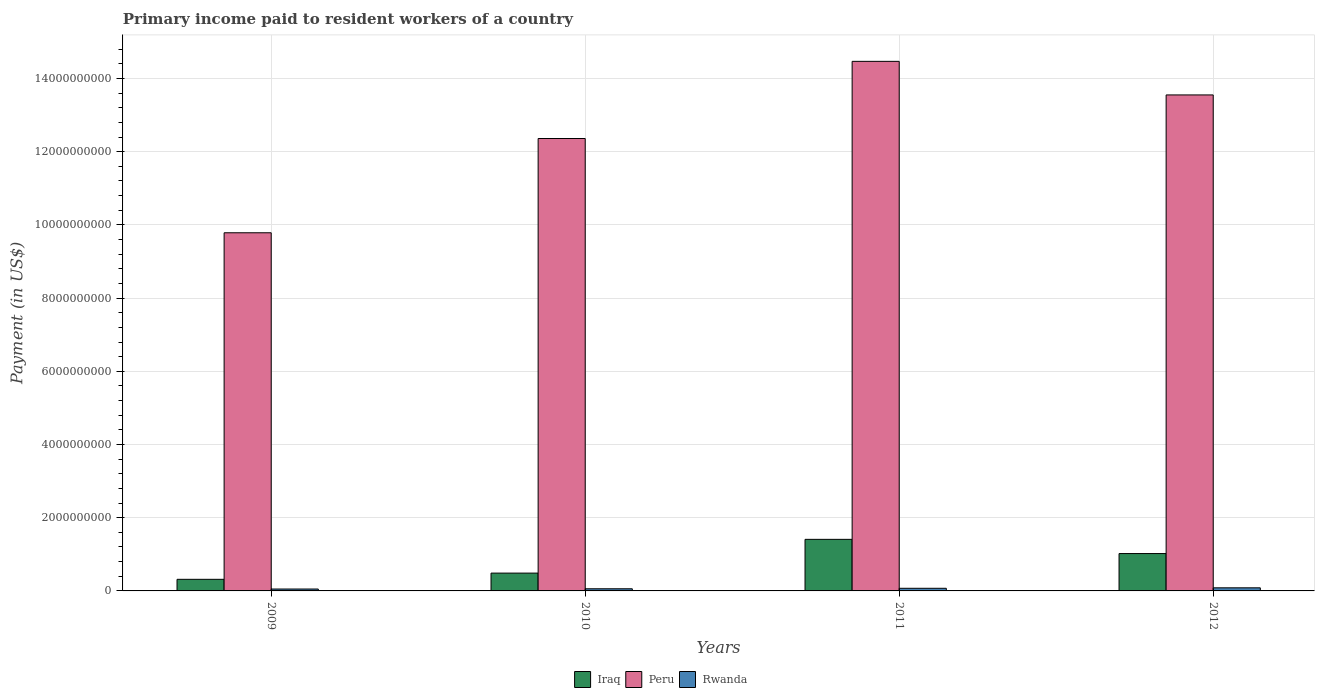How many groups of bars are there?
Offer a very short reply. 4. Are the number of bars per tick equal to the number of legend labels?
Your response must be concise. Yes. Are the number of bars on each tick of the X-axis equal?
Your answer should be very brief. Yes. How many bars are there on the 3rd tick from the left?
Provide a short and direct response. 3. What is the label of the 3rd group of bars from the left?
Your response must be concise. 2011. In how many cases, is the number of bars for a given year not equal to the number of legend labels?
Provide a succinct answer. 0. What is the amount paid to workers in Peru in 2010?
Make the answer very short. 1.24e+1. Across all years, what is the maximum amount paid to workers in Peru?
Ensure brevity in your answer.  1.45e+1. Across all years, what is the minimum amount paid to workers in Peru?
Give a very brief answer. 9.79e+09. In which year was the amount paid to workers in Rwanda maximum?
Your answer should be compact. 2012. In which year was the amount paid to workers in Peru minimum?
Your answer should be very brief. 2009. What is the total amount paid to workers in Iraq in the graph?
Provide a succinct answer. 3.23e+09. What is the difference between the amount paid to workers in Peru in 2009 and that in 2010?
Your response must be concise. -2.58e+09. What is the difference between the amount paid to workers in Iraq in 2011 and the amount paid to workers in Rwanda in 2012?
Your answer should be compact. 1.32e+09. What is the average amount paid to workers in Iraq per year?
Your response must be concise. 8.08e+08. In the year 2012, what is the difference between the amount paid to workers in Peru and amount paid to workers in Iraq?
Offer a terse response. 1.25e+1. In how many years, is the amount paid to workers in Rwanda greater than 9200000000 US$?
Your answer should be compact. 0. What is the ratio of the amount paid to workers in Peru in 2009 to that in 2012?
Provide a succinct answer. 0.72. What is the difference between the highest and the second highest amount paid to workers in Iraq?
Keep it short and to the point. 3.88e+08. What is the difference between the highest and the lowest amount paid to workers in Rwanda?
Your answer should be compact. 3.28e+07. What does the 3rd bar from the left in 2012 represents?
Your response must be concise. Rwanda. What does the 2nd bar from the right in 2010 represents?
Your answer should be compact. Peru. Is it the case that in every year, the sum of the amount paid to workers in Rwanda and amount paid to workers in Peru is greater than the amount paid to workers in Iraq?
Make the answer very short. Yes. How many bars are there?
Your answer should be compact. 12. Does the graph contain any zero values?
Your answer should be compact. No. Does the graph contain grids?
Your answer should be very brief. Yes. How many legend labels are there?
Offer a terse response. 3. How are the legend labels stacked?
Keep it short and to the point. Horizontal. What is the title of the graph?
Give a very brief answer. Primary income paid to resident workers of a country. Does "India" appear as one of the legend labels in the graph?
Your answer should be compact. No. What is the label or title of the X-axis?
Make the answer very short. Years. What is the label or title of the Y-axis?
Offer a terse response. Payment (in US$). What is the Payment (in US$) of Iraq in 2009?
Your answer should be compact. 3.17e+08. What is the Payment (in US$) of Peru in 2009?
Offer a very short reply. 9.79e+09. What is the Payment (in US$) in Rwanda in 2009?
Give a very brief answer. 5.17e+07. What is the Payment (in US$) of Iraq in 2010?
Your answer should be very brief. 4.87e+08. What is the Payment (in US$) of Peru in 2010?
Provide a short and direct response. 1.24e+1. What is the Payment (in US$) of Rwanda in 2010?
Offer a very short reply. 5.86e+07. What is the Payment (in US$) in Iraq in 2011?
Keep it short and to the point. 1.41e+09. What is the Payment (in US$) of Peru in 2011?
Your response must be concise. 1.45e+1. What is the Payment (in US$) of Rwanda in 2011?
Keep it short and to the point. 7.19e+07. What is the Payment (in US$) in Iraq in 2012?
Provide a succinct answer. 1.02e+09. What is the Payment (in US$) of Peru in 2012?
Keep it short and to the point. 1.36e+1. What is the Payment (in US$) of Rwanda in 2012?
Make the answer very short. 8.45e+07. Across all years, what is the maximum Payment (in US$) of Iraq?
Offer a very short reply. 1.41e+09. Across all years, what is the maximum Payment (in US$) of Peru?
Provide a short and direct response. 1.45e+1. Across all years, what is the maximum Payment (in US$) in Rwanda?
Give a very brief answer. 8.45e+07. Across all years, what is the minimum Payment (in US$) of Iraq?
Your response must be concise. 3.17e+08. Across all years, what is the minimum Payment (in US$) of Peru?
Offer a very short reply. 9.79e+09. Across all years, what is the minimum Payment (in US$) of Rwanda?
Keep it short and to the point. 5.17e+07. What is the total Payment (in US$) of Iraq in the graph?
Your response must be concise. 3.23e+09. What is the total Payment (in US$) in Peru in the graph?
Keep it short and to the point. 5.02e+1. What is the total Payment (in US$) of Rwanda in the graph?
Your answer should be very brief. 2.67e+08. What is the difference between the Payment (in US$) in Iraq in 2009 and that in 2010?
Give a very brief answer. -1.70e+08. What is the difference between the Payment (in US$) of Peru in 2009 and that in 2010?
Give a very brief answer. -2.58e+09. What is the difference between the Payment (in US$) in Rwanda in 2009 and that in 2010?
Offer a terse response. -6.93e+06. What is the difference between the Payment (in US$) in Iraq in 2009 and that in 2011?
Your answer should be compact. -1.09e+09. What is the difference between the Payment (in US$) of Peru in 2009 and that in 2011?
Provide a succinct answer. -4.68e+09. What is the difference between the Payment (in US$) in Rwanda in 2009 and that in 2011?
Give a very brief answer. -2.02e+07. What is the difference between the Payment (in US$) in Iraq in 2009 and that in 2012?
Your answer should be compact. -7.04e+08. What is the difference between the Payment (in US$) of Peru in 2009 and that in 2012?
Provide a succinct answer. -3.77e+09. What is the difference between the Payment (in US$) in Rwanda in 2009 and that in 2012?
Provide a short and direct response. -3.28e+07. What is the difference between the Payment (in US$) of Iraq in 2010 and that in 2011?
Your answer should be very brief. -9.22e+08. What is the difference between the Payment (in US$) of Peru in 2010 and that in 2011?
Your answer should be compact. -2.11e+09. What is the difference between the Payment (in US$) of Rwanda in 2010 and that in 2011?
Give a very brief answer. -1.32e+07. What is the difference between the Payment (in US$) of Iraq in 2010 and that in 2012?
Your answer should be compact. -5.34e+08. What is the difference between the Payment (in US$) of Peru in 2010 and that in 2012?
Keep it short and to the point. -1.19e+09. What is the difference between the Payment (in US$) of Rwanda in 2010 and that in 2012?
Your response must be concise. -2.59e+07. What is the difference between the Payment (in US$) in Iraq in 2011 and that in 2012?
Your answer should be very brief. 3.88e+08. What is the difference between the Payment (in US$) in Peru in 2011 and that in 2012?
Your answer should be compact. 9.17e+08. What is the difference between the Payment (in US$) of Rwanda in 2011 and that in 2012?
Your response must be concise. -1.27e+07. What is the difference between the Payment (in US$) in Iraq in 2009 and the Payment (in US$) in Peru in 2010?
Give a very brief answer. -1.20e+1. What is the difference between the Payment (in US$) of Iraq in 2009 and the Payment (in US$) of Rwanda in 2010?
Your answer should be compact. 2.58e+08. What is the difference between the Payment (in US$) in Peru in 2009 and the Payment (in US$) in Rwanda in 2010?
Your response must be concise. 9.73e+09. What is the difference between the Payment (in US$) in Iraq in 2009 and the Payment (in US$) in Peru in 2011?
Your answer should be compact. -1.42e+1. What is the difference between the Payment (in US$) in Iraq in 2009 and the Payment (in US$) in Rwanda in 2011?
Keep it short and to the point. 2.45e+08. What is the difference between the Payment (in US$) in Peru in 2009 and the Payment (in US$) in Rwanda in 2011?
Keep it short and to the point. 9.71e+09. What is the difference between the Payment (in US$) in Iraq in 2009 and the Payment (in US$) in Peru in 2012?
Provide a short and direct response. -1.32e+1. What is the difference between the Payment (in US$) in Iraq in 2009 and the Payment (in US$) in Rwanda in 2012?
Your answer should be very brief. 2.33e+08. What is the difference between the Payment (in US$) in Peru in 2009 and the Payment (in US$) in Rwanda in 2012?
Provide a succinct answer. 9.70e+09. What is the difference between the Payment (in US$) in Iraq in 2010 and the Payment (in US$) in Peru in 2011?
Ensure brevity in your answer.  -1.40e+1. What is the difference between the Payment (in US$) in Iraq in 2010 and the Payment (in US$) in Rwanda in 2011?
Offer a very short reply. 4.15e+08. What is the difference between the Payment (in US$) in Peru in 2010 and the Payment (in US$) in Rwanda in 2011?
Provide a succinct answer. 1.23e+1. What is the difference between the Payment (in US$) of Iraq in 2010 and the Payment (in US$) of Peru in 2012?
Provide a short and direct response. -1.31e+1. What is the difference between the Payment (in US$) of Iraq in 2010 and the Payment (in US$) of Rwanda in 2012?
Provide a succinct answer. 4.02e+08. What is the difference between the Payment (in US$) of Peru in 2010 and the Payment (in US$) of Rwanda in 2012?
Your response must be concise. 1.23e+1. What is the difference between the Payment (in US$) in Iraq in 2011 and the Payment (in US$) in Peru in 2012?
Provide a short and direct response. -1.21e+1. What is the difference between the Payment (in US$) of Iraq in 2011 and the Payment (in US$) of Rwanda in 2012?
Provide a succinct answer. 1.32e+09. What is the difference between the Payment (in US$) of Peru in 2011 and the Payment (in US$) of Rwanda in 2012?
Your answer should be very brief. 1.44e+1. What is the average Payment (in US$) of Iraq per year?
Provide a short and direct response. 8.08e+08. What is the average Payment (in US$) of Peru per year?
Offer a very short reply. 1.25e+1. What is the average Payment (in US$) in Rwanda per year?
Give a very brief answer. 6.67e+07. In the year 2009, what is the difference between the Payment (in US$) in Iraq and Payment (in US$) in Peru?
Ensure brevity in your answer.  -9.47e+09. In the year 2009, what is the difference between the Payment (in US$) of Iraq and Payment (in US$) of Rwanda?
Your answer should be very brief. 2.65e+08. In the year 2009, what is the difference between the Payment (in US$) in Peru and Payment (in US$) in Rwanda?
Keep it short and to the point. 9.73e+09. In the year 2010, what is the difference between the Payment (in US$) of Iraq and Payment (in US$) of Peru?
Give a very brief answer. -1.19e+1. In the year 2010, what is the difference between the Payment (in US$) of Iraq and Payment (in US$) of Rwanda?
Your answer should be very brief. 4.28e+08. In the year 2010, what is the difference between the Payment (in US$) in Peru and Payment (in US$) in Rwanda?
Provide a succinct answer. 1.23e+1. In the year 2011, what is the difference between the Payment (in US$) of Iraq and Payment (in US$) of Peru?
Your answer should be compact. -1.31e+1. In the year 2011, what is the difference between the Payment (in US$) in Iraq and Payment (in US$) in Rwanda?
Keep it short and to the point. 1.34e+09. In the year 2011, what is the difference between the Payment (in US$) in Peru and Payment (in US$) in Rwanda?
Keep it short and to the point. 1.44e+1. In the year 2012, what is the difference between the Payment (in US$) in Iraq and Payment (in US$) in Peru?
Offer a very short reply. -1.25e+1. In the year 2012, what is the difference between the Payment (in US$) of Iraq and Payment (in US$) of Rwanda?
Offer a very short reply. 9.36e+08. In the year 2012, what is the difference between the Payment (in US$) of Peru and Payment (in US$) of Rwanda?
Provide a succinct answer. 1.35e+1. What is the ratio of the Payment (in US$) of Iraq in 2009 to that in 2010?
Provide a succinct answer. 0.65. What is the ratio of the Payment (in US$) of Peru in 2009 to that in 2010?
Make the answer very short. 0.79. What is the ratio of the Payment (in US$) in Rwanda in 2009 to that in 2010?
Provide a succinct answer. 0.88. What is the ratio of the Payment (in US$) of Iraq in 2009 to that in 2011?
Provide a short and direct response. 0.23. What is the ratio of the Payment (in US$) of Peru in 2009 to that in 2011?
Make the answer very short. 0.68. What is the ratio of the Payment (in US$) of Rwanda in 2009 to that in 2011?
Provide a succinct answer. 0.72. What is the ratio of the Payment (in US$) of Iraq in 2009 to that in 2012?
Ensure brevity in your answer.  0.31. What is the ratio of the Payment (in US$) of Peru in 2009 to that in 2012?
Your response must be concise. 0.72. What is the ratio of the Payment (in US$) in Rwanda in 2009 to that in 2012?
Offer a terse response. 0.61. What is the ratio of the Payment (in US$) of Iraq in 2010 to that in 2011?
Provide a succinct answer. 0.35. What is the ratio of the Payment (in US$) in Peru in 2010 to that in 2011?
Your response must be concise. 0.85. What is the ratio of the Payment (in US$) of Rwanda in 2010 to that in 2011?
Your answer should be very brief. 0.82. What is the ratio of the Payment (in US$) of Iraq in 2010 to that in 2012?
Make the answer very short. 0.48. What is the ratio of the Payment (in US$) in Peru in 2010 to that in 2012?
Your response must be concise. 0.91. What is the ratio of the Payment (in US$) in Rwanda in 2010 to that in 2012?
Ensure brevity in your answer.  0.69. What is the ratio of the Payment (in US$) of Iraq in 2011 to that in 2012?
Provide a succinct answer. 1.38. What is the ratio of the Payment (in US$) in Peru in 2011 to that in 2012?
Give a very brief answer. 1.07. What is the ratio of the Payment (in US$) of Rwanda in 2011 to that in 2012?
Keep it short and to the point. 0.85. What is the difference between the highest and the second highest Payment (in US$) in Iraq?
Your response must be concise. 3.88e+08. What is the difference between the highest and the second highest Payment (in US$) in Peru?
Provide a succinct answer. 9.17e+08. What is the difference between the highest and the second highest Payment (in US$) of Rwanda?
Provide a short and direct response. 1.27e+07. What is the difference between the highest and the lowest Payment (in US$) of Iraq?
Your answer should be very brief. 1.09e+09. What is the difference between the highest and the lowest Payment (in US$) in Peru?
Provide a succinct answer. 4.68e+09. What is the difference between the highest and the lowest Payment (in US$) of Rwanda?
Offer a very short reply. 3.28e+07. 